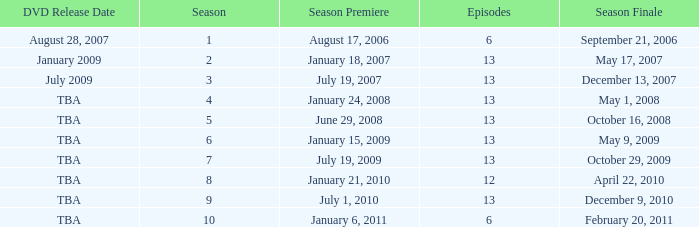On what date was the DVD released for the season with fewer than 13 episodes that aired before season 8? August 28, 2007. 